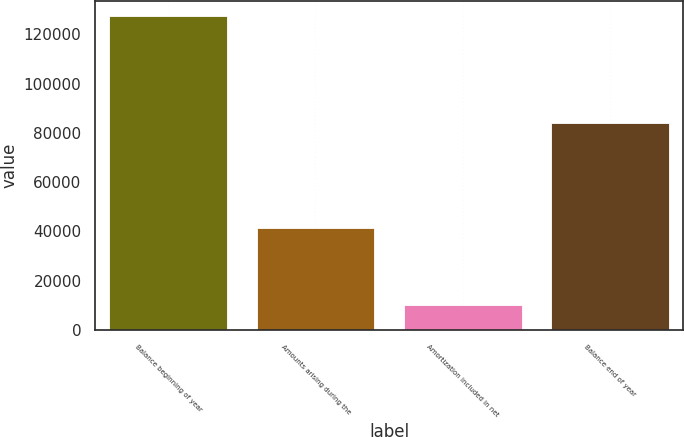Convert chart. <chart><loc_0><loc_0><loc_500><loc_500><bar_chart><fcel>Balance beginning of year<fcel>Amounts arising during the<fcel>Amortization included in net<fcel>Balance end of year<nl><fcel>127292<fcel>41532<fcel>10218<fcel>84122<nl></chart> 